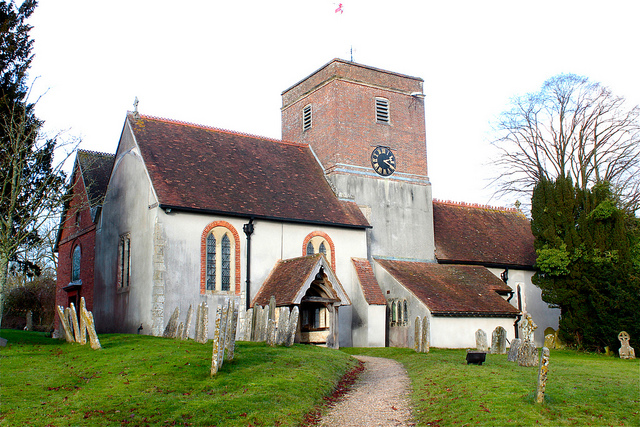<image>What time is showing on the clock? I am not sure what time is showing on the clock. It can be 2:20, 3:20 or 2:40. What time is showing on the clock? I am not sure what time is showing on the clock. It can be seen as 2:20 or 2:40. 